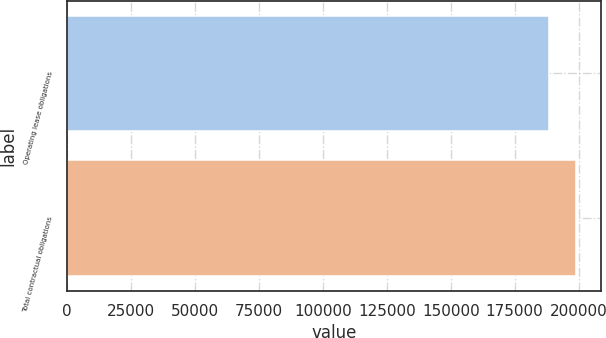Convert chart to OTSL. <chart><loc_0><loc_0><loc_500><loc_500><bar_chart><fcel>Operating lease obligations<fcel>Total contractual obligations<nl><fcel>188387<fcel>198834<nl></chart> 